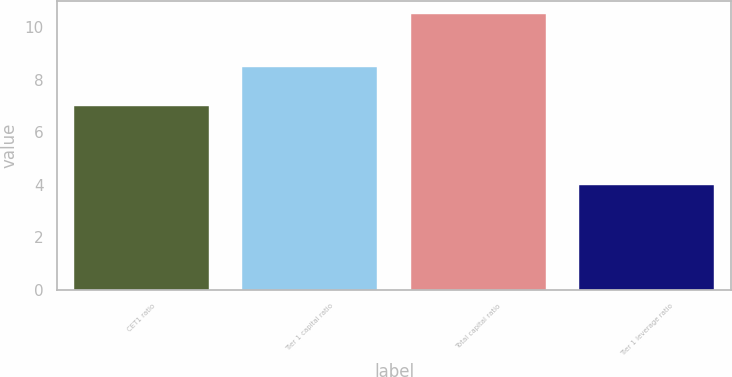Convert chart to OTSL. <chart><loc_0><loc_0><loc_500><loc_500><bar_chart><fcel>CET1 ratio<fcel>Tier 1 capital ratio<fcel>Total capital ratio<fcel>Tier 1 leverage ratio<nl><fcel>7<fcel>8.5<fcel>10.5<fcel>4<nl></chart> 